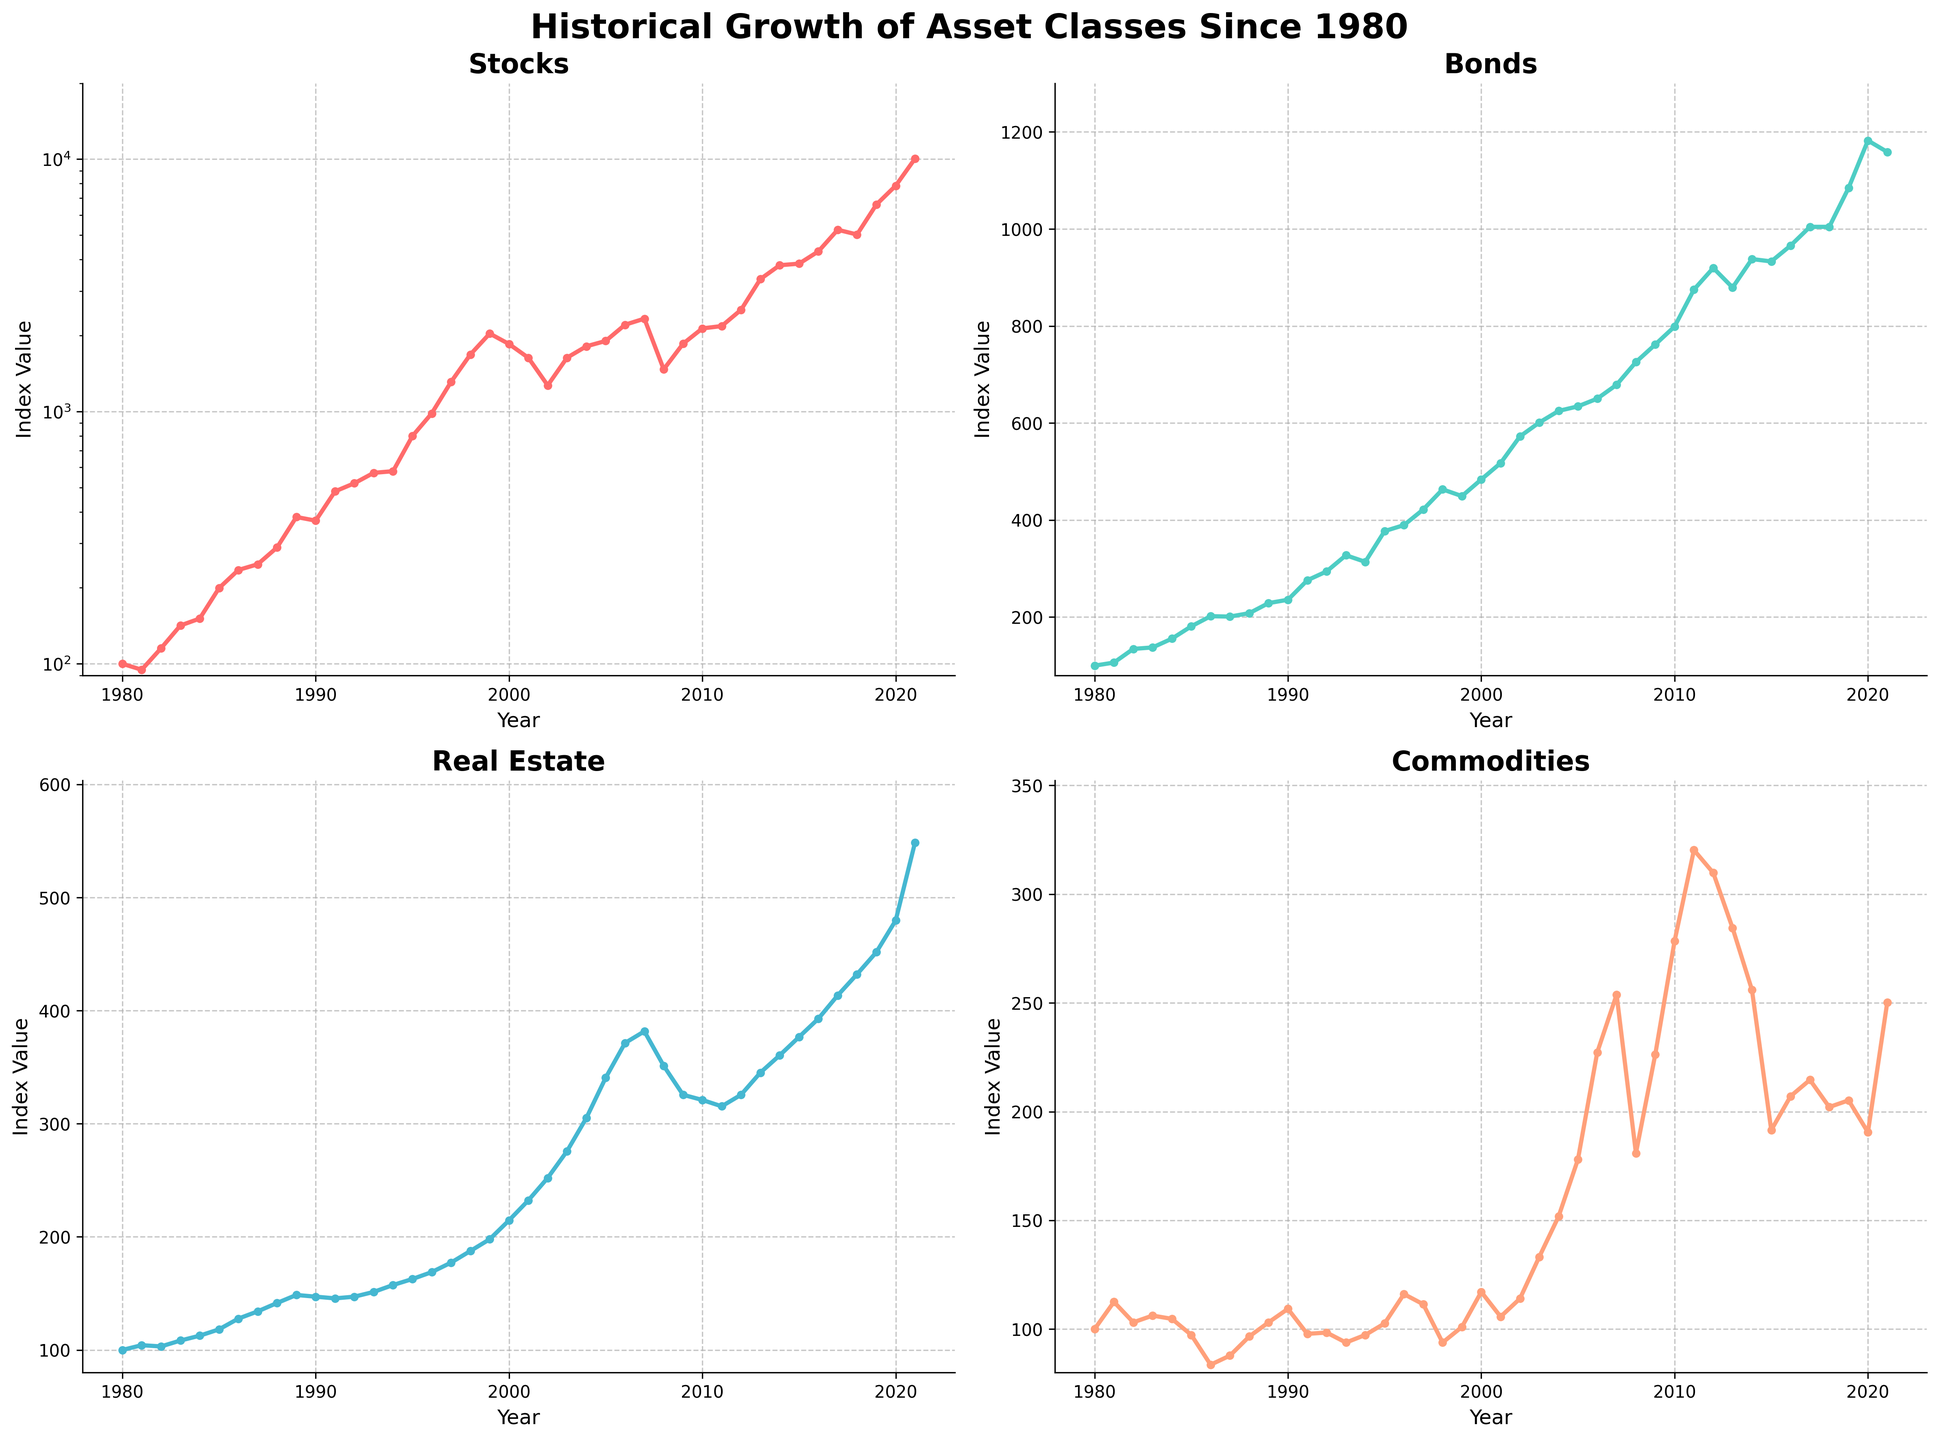what is the average value of the Bonds index between 1990 and 2000? To calculate the average, add up the values of the 'Bonds' index from 1990 to 2000 and divide by the number of years (11). The values are 235.8, 275.9, 294.2, 327.5, 313.9, 377.3, 389.6, 421.9, 463.3, 449.4, and 483.7. Summing these gives 4032.5. Dividing by 11 gives approximately 366.59
Answer: 366.59 Which asset class had the highest index value in 1980? Looking at the plot, the index values for 1980 show that all asset classes (Stocks, Bonds, Real Estate, Commodities) started at 100. Therefore, any asset class could be considered as having the highest index at 1980 since they are equal.
Answer: All are equal In which year did the value of the Stocks index exceed 5000? Observing the Stocks subplot, you can see that the index value exceeds 5000 in 2017.
Answer: 2017 Compare 2008 and 2009 for the Stocks index. Did it decline or increase, and by how much? Observing the subplots, the Stocks index declined from 2331.9 in 2007 to 1468.4 in 2008 and then increased to 1855.0 in 2009. To find the change from 2008 to 2009, subtract 1468.4 from 1855.0, which equals 386.6. Hence, there was an increase of 386.6 from 2008 to 2009
Answer: Increased by 386.6 Between 2010 and 2015, which asset class saw the most considerable relative growth? Calculate the relative growth for each asset class by comparing the index values in 2010 and 2015. Stocks: (3851.7 - 2134.0) / 2134.0 ≈ 0.805, Bonds: (933.1 - 799.0) / 799.0 ≈ 0.168, Real Estate: (376.7 - 321.0) / 321.0 ≈ 0.173, Commodities: (191.5 - 278.5) / 278.5 ≈ -0.312. Stocks had the most considerable relative growth at approximately 80.5%.
Answer: Stocks What is the color of the line representing the Real Estate index? The Real Estate line in the subplot is shown in blue color.
Answer: Blue Which year had the greatest value for the Commodities index? Looking at the Commodities subplot, the highest value occurs in the year 2011 with a value of 320.3
Answer: 2011 Compare the trend of Bonds and Real Estate indices from 1990 to 2000. Which one has shown more variability? By examining the indices for Bonds and Real Estate from 1990 to 2000, the Bonds index shows a more erratic trend, increasing from 235.8 to 483.7 with fluctuations, whereas Real Estate shows a more steady growth from 147.1 to 214.6. Therefore, Bonds show more variability.
Answer: Bonds From 2000 to 2010, which asset class experienced both a rise and a fall? Reviewing the trends, both Stocks and Commodities exhibit rises and falls within the period. Stocks fell from 2000 to 2002, and then rose after 2002. Commodities peaked in 2007 then fell afterward. Both Stocks and Commodities experienced rises and falls.
Answer: Stocks and Commodities 